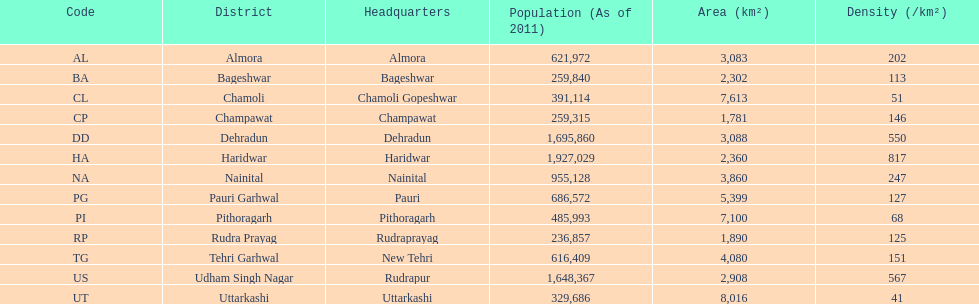Which possesses a greater population, dehradun or nainital? Dehradun. 